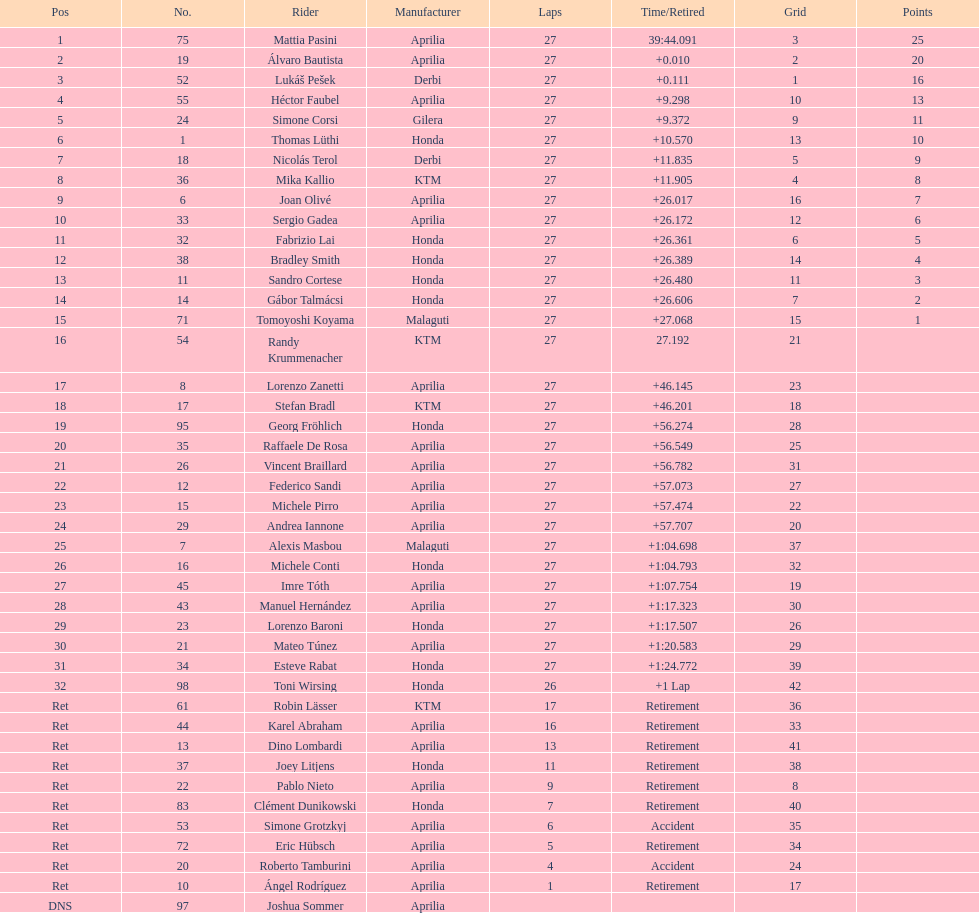Can you give me this table as a dict? {'header': ['Pos', 'No.', 'Rider', 'Manufacturer', 'Laps', 'Time/Retired', 'Grid', 'Points'], 'rows': [['1', '75', 'Mattia Pasini', 'Aprilia', '27', '39:44.091', '3', '25'], ['2', '19', 'Álvaro Bautista', 'Aprilia', '27', '+0.010', '2', '20'], ['3', '52', 'Lukáš Pešek', 'Derbi', '27', '+0.111', '1', '16'], ['4', '55', 'Héctor Faubel', 'Aprilia', '27', '+9.298', '10', '13'], ['5', '24', 'Simone Corsi', 'Gilera', '27', '+9.372', '9', '11'], ['6', '1', 'Thomas Lüthi', 'Honda', '27', '+10.570', '13', '10'], ['7', '18', 'Nicolás Terol', 'Derbi', '27', '+11.835', '5', '9'], ['8', '36', 'Mika Kallio', 'KTM', '27', '+11.905', '4', '8'], ['9', '6', 'Joan Olivé', 'Aprilia', '27', '+26.017', '16', '7'], ['10', '33', 'Sergio Gadea', 'Aprilia', '27', '+26.172', '12', '6'], ['11', '32', 'Fabrizio Lai', 'Honda', '27', '+26.361', '6', '5'], ['12', '38', 'Bradley Smith', 'Honda', '27', '+26.389', '14', '4'], ['13', '11', 'Sandro Cortese', 'Honda', '27', '+26.480', '11', '3'], ['14', '14', 'Gábor Talmácsi', 'Honda', '27', '+26.606', '7', '2'], ['15', '71', 'Tomoyoshi Koyama', 'Malaguti', '27', '+27.068', '15', '1'], ['16', '54', 'Randy Krummenacher', 'KTM', '27', '27.192', '21', ''], ['17', '8', 'Lorenzo Zanetti', 'Aprilia', '27', '+46.145', '23', ''], ['18', '17', 'Stefan Bradl', 'KTM', '27', '+46.201', '18', ''], ['19', '95', 'Georg Fröhlich', 'Honda', '27', '+56.274', '28', ''], ['20', '35', 'Raffaele De Rosa', 'Aprilia', '27', '+56.549', '25', ''], ['21', '26', 'Vincent Braillard', 'Aprilia', '27', '+56.782', '31', ''], ['22', '12', 'Federico Sandi', 'Aprilia', '27', '+57.073', '27', ''], ['23', '15', 'Michele Pirro', 'Aprilia', '27', '+57.474', '22', ''], ['24', '29', 'Andrea Iannone', 'Aprilia', '27', '+57.707', '20', ''], ['25', '7', 'Alexis Masbou', 'Malaguti', '27', '+1:04.698', '37', ''], ['26', '16', 'Michele Conti', 'Honda', '27', '+1:04.793', '32', ''], ['27', '45', 'Imre Tóth', 'Aprilia', '27', '+1:07.754', '19', ''], ['28', '43', 'Manuel Hernández', 'Aprilia', '27', '+1:17.323', '30', ''], ['29', '23', 'Lorenzo Baroni', 'Honda', '27', '+1:17.507', '26', ''], ['30', '21', 'Mateo Túnez', 'Aprilia', '27', '+1:20.583', '29', ''], ['31', '34', 'Esteve Rabat', 'Honda', '27', '+1:24.772', '39', ''], ['32', '98', 'Toni Wirsing', 'Honda', '26', '+1 Lap', '42', ''], ['Ret', '61', 'Robin Lässer', 'KTM', '17', 'Retirement', '36', ''], ['Ret', '44', 'Karel Abraham', 'Aprilia', '16', 'Retirement', '33', ''], ['Ret', '13', 'Dino Lombardi', 'Aprilia', '13', 'Retirement', '41', ''], ['Ret', '37', 'Joey Litjens', 'Honda', '11', 'Retirement', '38', ''], ['Ret', '22', 'Pablo Nieto', 'Aprilia', '9', 'Retirement', '8', ''], ['Ret', '83', 'Clément Dunikowski', 'Honda', '7', 'Retirement', '40', ''], ['Ret', '53', 'Simone Grotzkyj', 'Aprilia', '6', 'Accident', '35', ''], ['Ret', '72', 'Eric Hübsch', 'Aprilia', '5', 'Retirement', '34', ''], ['Ret', '20', 'Roberto Tamburini', 'Aprilia', '4', 'Accident', '24', ''], ['Ret', '10', 'Ángel Rodríguez', 'Aprilia', '1', 'Retirement', '17', ''], ['DNS', '97', 'Joshua Sommer', 'Aprilia', '', '', '', '']]} How many positions were there in total within the 125cc classification? 43. 